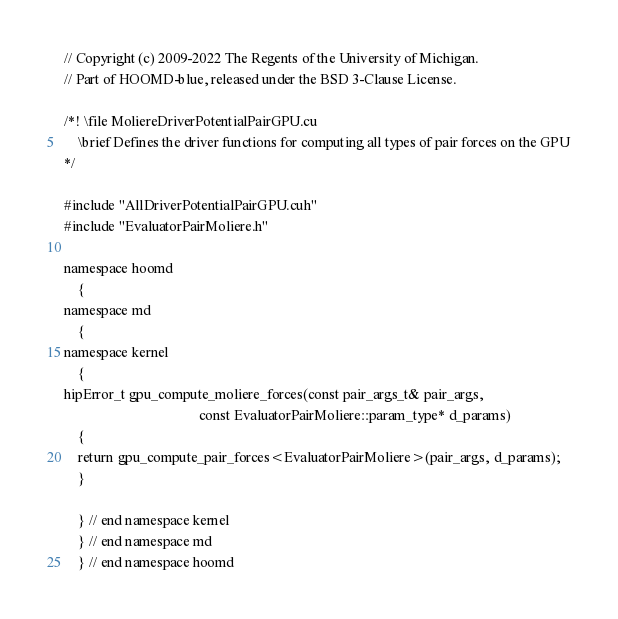Convert code to text. <code><loc_0><loc_0><loc_500><loc_500><_Cuda_>// Copyright (c) 2009-2022 The Regents of the University of Michigan.
// Part of HOOMD-blue, released under the BSD 3-Clause License.

/*! \file MoliereDriverPotentialPairGPU.cu
    \brief Defines the driver functions for computing all types of pair forces on the GPU
*/

#include "AllDriverPotentialPairGPU.cuh"
#include "EvaluatorPairMoliere.h"

namespace hoomd
    {
namespace md
    {
namespace kernel
    {
hipError_t gpu_compute_moliere_forces(const pair_args_t& pair_args,
                                      const EvaluatorPairMoliere::param_type* d_params)
    {
    return gpu_compute_pair_forces<EvaluatorPairMoliere>(pair_args, d_params);
    }

    } // end namespace kernel
    } // end namespace md
    } // end namespace hoomd
</code> 